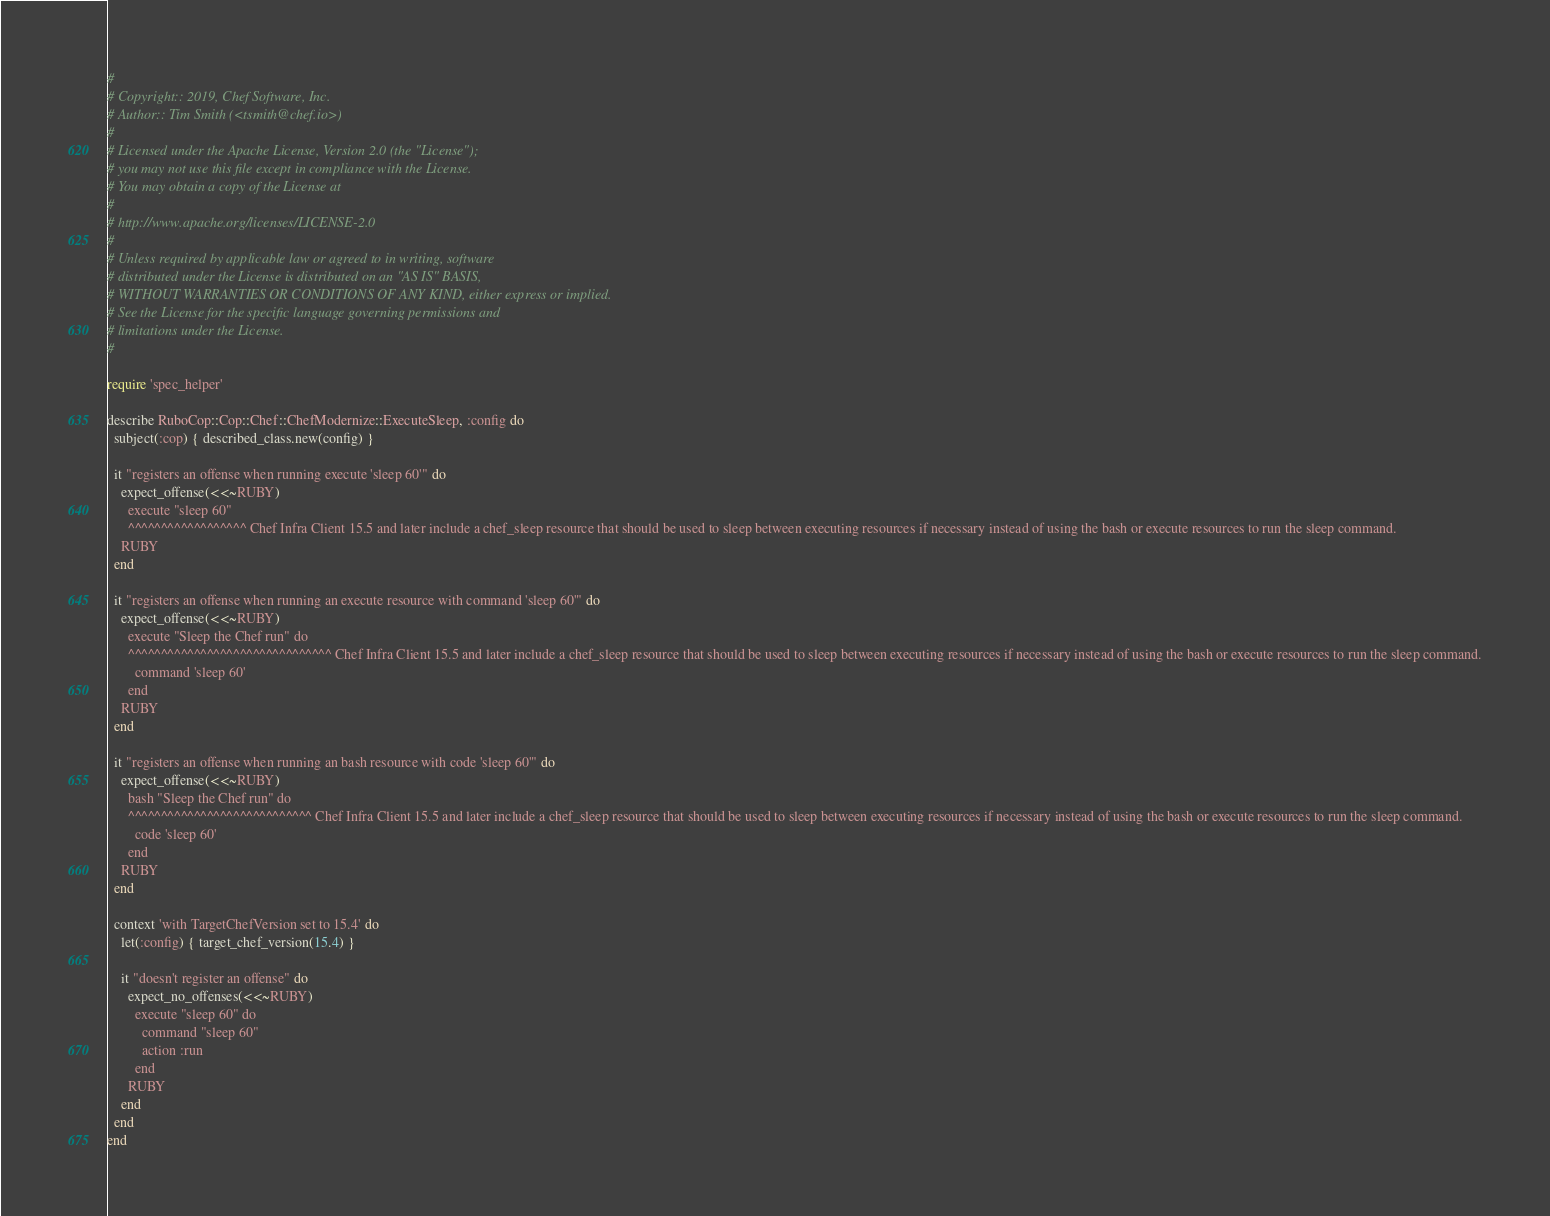<code> <loc_0><loc_0><loc_500><loc_500><_Ruby_>#
# Copyright:: 2019, Chef Software, Inc.
# Author:: Tim Smith (<tsmith@chef.io>)
#
# Licensed under the Apache License, Version 2.0 (the "License");
# you may not use this file except in compliance with the License.
# You may obtain a copy of the License at
#
# http://www.apache.org/licenses/LICENSE-2.0
#
# Unless required by applicable law or agreed to in writing, software
# distributed under the License is distributed on an "AS IS" BASIS,
# WITHOUT WARRANTIES OR CONDITIONS OF ANY KIND, either express or implied.
# See the License for the specific language governing permissions and
# limitations under the License.
#

require 'spec_helper'

describe RuboCop::Cop::Chef::ChefModernize::ExecuteSleep, :config do
  subject(:cop) { described_class.new(config) }

  it "registers an offense when running execute 'sleep 60'" do
    expect_offense(<<~RUBY)
      execute "sleep 60"
      ^^^^^^^^^^^^^^^^^^ Chef Infra Client 15.5 and later include a chef_sleep resource that should be used to sleep between executing resources if necessary instead of using the bash or execute resources to run the sleep command.
    RUBY
  end

  it "registers an offense when running an execute resource with command 'sleep 60'" do
    expect_offense(<<~RUBY)
      execute "Sleep the Chef run" do
      ^^^^^^^^^^^^^^^^^^^^^^^^^^^^^^^ Chef Infra Client 15.5 and later include a chef_sleep resource that should be used to sleep between executing resources if necessary instead of using the bash or execute resources to run the sleep command.
        command 'sleep 60'
      end
    RUBY
  end

  it "registers an offense when running an bash resource with code 'sleep 60'" do
    expect_offense(<<~RUBY)
      bash "Sleep the Chef run" do
      ^^^^^^^^^^^^^^^^^^^^^^^^^^^^ Chef Infra Client 15.5 and later include a chef_sleep resource that should be used to sleep between executing resources if necessary instead of using the bash or execute resources to run the sleep command.
        code 'sleep 60'
      end
    RUBY
  end

  context 'with TargetChefVersion set to 15.4' do
    let(:config) { target_chef_version(15.4) }

    it "doesn't register an offense" do
      expect_no_offenses(<<~RUBY)
        execute "sleep 60" do
          command "sleep 60"
          action :run
        end
      RUBY
    end
  end
end
</code> 